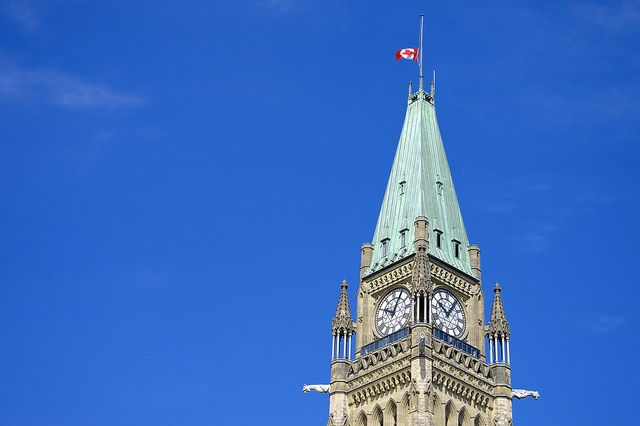<image>Where is this cathedral located? I don't know exactly where this cathedral is located, but it could possibly be in Canada, Germany, Italy, or another unspecified city. Where is this cathedral located? I don't know where this cathedral is located. However, it can be in Canada, Italy, or Germany. 